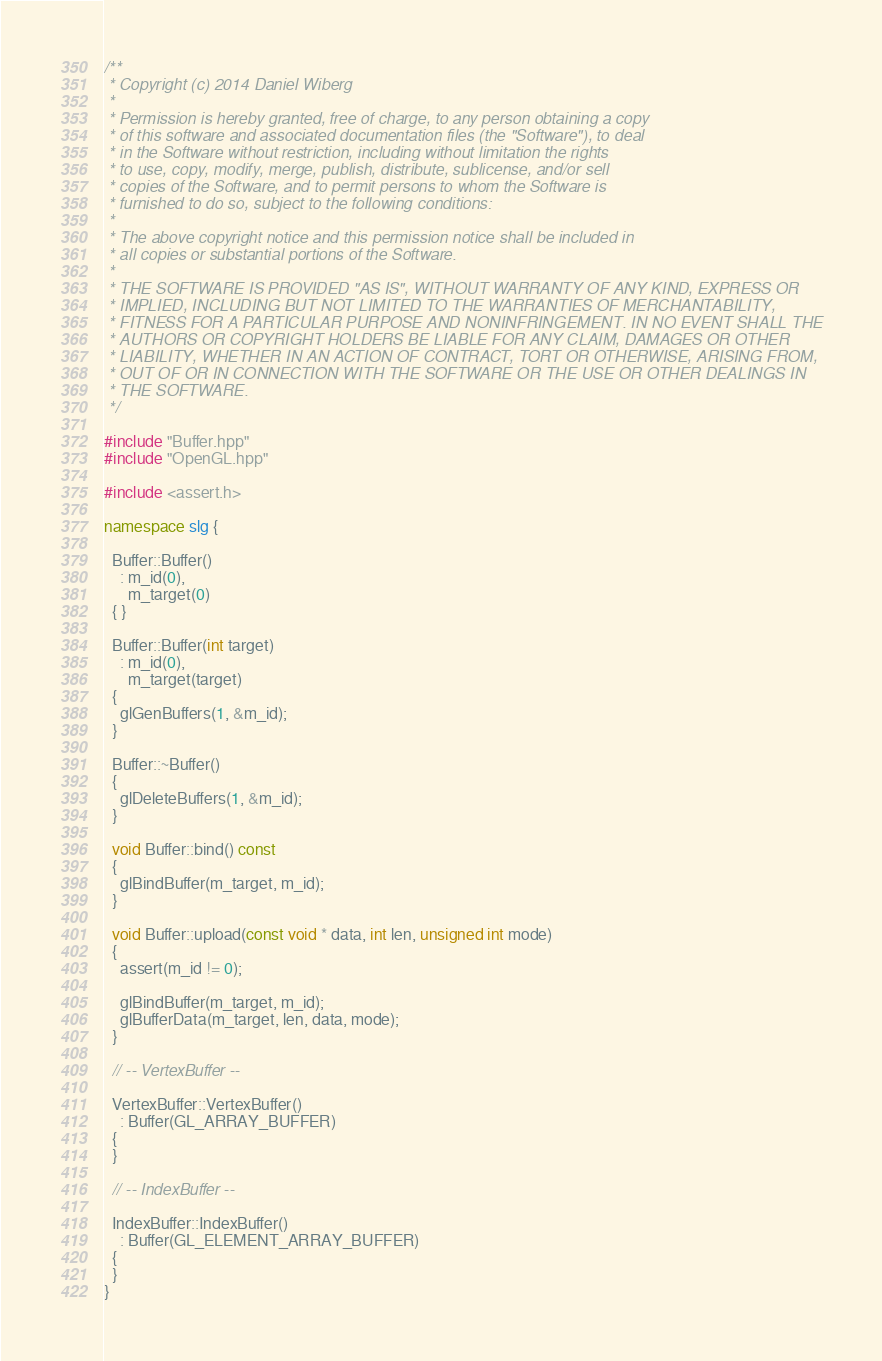<code> <loc_0><loc_0><loc_500><loc_500><_C++_>/**
 * Copyright (c) 2014 Daniel Wiberg
 *
 * Permission is hereby granted, free of charge, to any person obtaining a copy
 * of this software and associated documentation files (the "Software"), to deal
 * in the Software without restriction, including without limitation the rights
 * to use, copy, modify, merge, publish, distribute, sublicense, and/or sell
 * copies of the Software, and to permit persons to whom the Software is
 * furnished to do so, subject to the following conditions:
 *
 * The above copyright notice and this permission notice shall be included in
 * all copies or substantial portions of the Software.
 *
 * THE SOFTWARE IS PROVIDED "AS IS", WITHOUT WARRANTY OF ANY KIND, EXPRESS OR
 * IMPLIED, INCLUDING BUT NOT LIMITED TO THE WARRANTIES OF MERCHANTABILITY,
 * FITNESS FOR A PARTICULAR PURPOSE AND NONINFRINGEMENT. IN NO EVENT SHALL THE
 * AUTHORS OR COPYRIGHT HOLDERS BE LIABLE FOR ANY CLAIM, DAMAGES OR OTHER
 * LIABILITY, WHETHER IN AN ACTION OF CONTRACT, TORT OR OTHERWISE, ARISING FROM,
 * OUT OF OR IN CONNECTION WITH THE SOFTWARE OR THE USE OR OTHER DEALINGS IN
 * THE SOFTWARE.
 */

#include "Buffer.hpp"
#include "OpenGL.hpp"

#include <assert.h>

namespace slg {

  Buffer::Buffer()
    : m_id(0),
      m_target(0)
  { }

  Buffer::Buffer(int target)
    : m_id(0),
      m_target(target)
  {
    glGenBuffers(1, &m_id);
  }

  Buffer::~Buffer()
  {
    glDeleteBuffers(1, &m_id);
  }

  void Buffer::bind() const
  {
    glBindBuffer(m_target, m_id);
  }

  void Buffer::upload(const void * data, int len, unsigned int mode)
  {
    assert(m_id != 0);

    glBindBuffer(m_target, m_id);
    glBufferData(m_target, len, data, mode);
  }

  // -- VertexBuffer --

  VertexBuffer::VertexBuffer()
    : Buffer(GL_ARRAY_BUFFER)
  {
  }

  // -- IndexBuffer --

  IndexBuffer::IndexBuffer()
    : Buffer(GL_ELEMENT_ARRAY_BUFFER)
  {
  }
}
</code> 